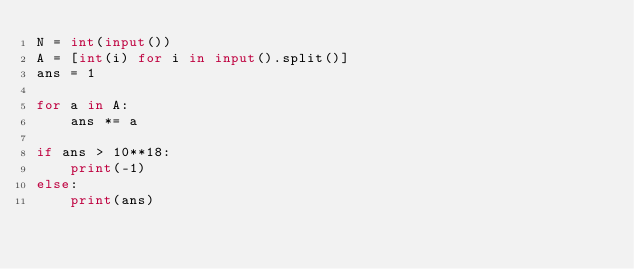Convert code to text. <code><loc_0><loc_0><loc_500><loc_500><_Python_>N = int(input())
A = [int(i) for i in input().split()]
ans = 1

for a in A:
    ans *= a

if ans > 10**18:
    print(-1)
else:
    print(ans)</code> 